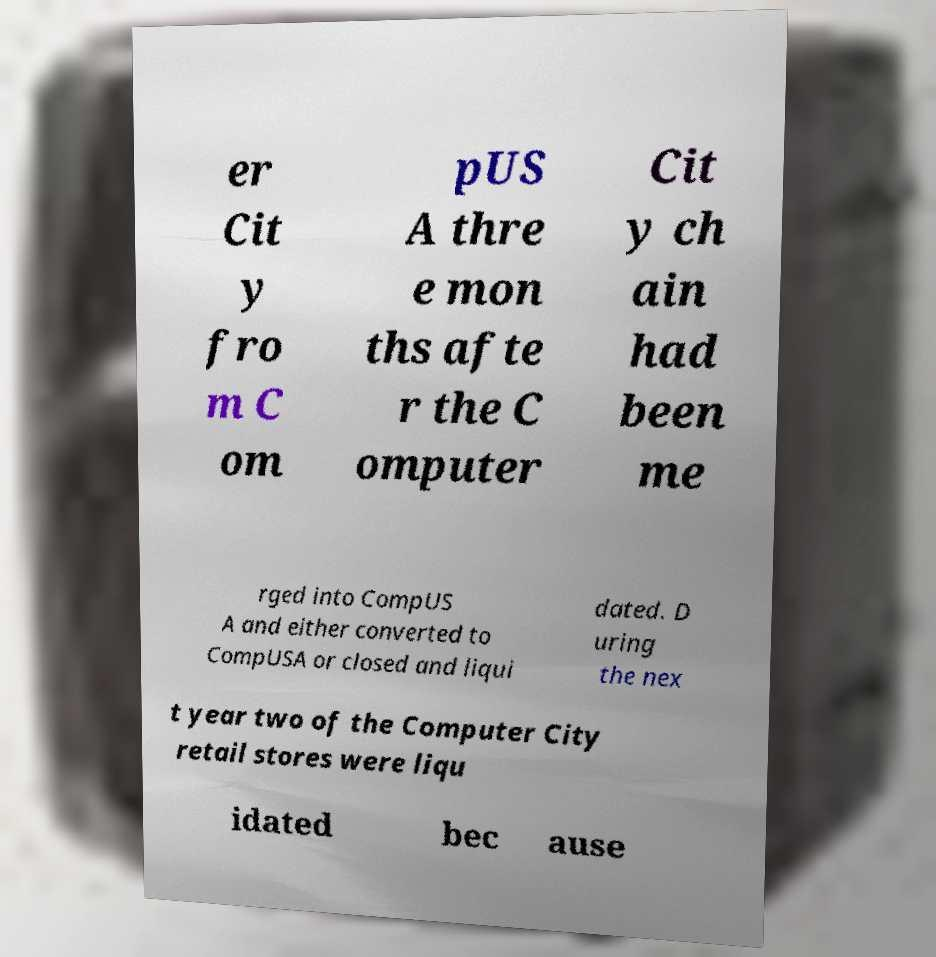Could you assist in decoding the text presented in this image and type it out clearly? er Cit y fro m C om pUS A thre e mon ths afte r the C omputer Cit y ch ain had been me rged into CompUS A and either converted to CompUSA or closed and liqui dated. D uring the nex t year two of the Computer City retail stores were liqu idated bec ause 